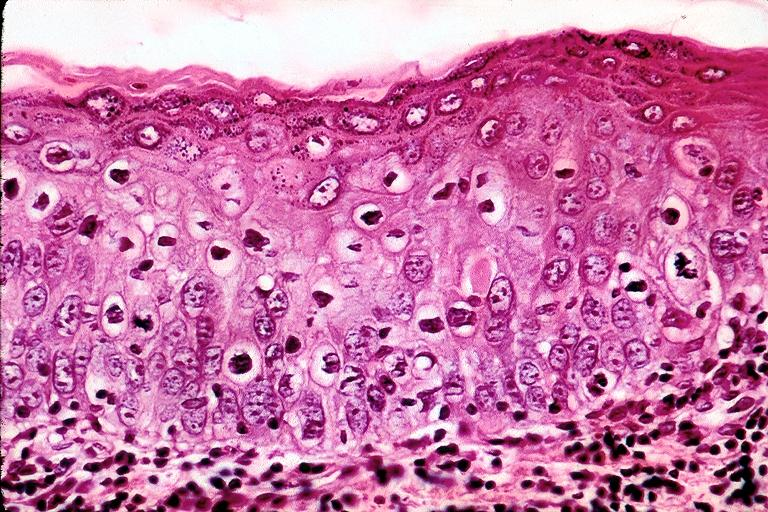does newborn cord around neck show mild-moderate epithelial dysplasia?
Answer the question using a single word or phrase. No 